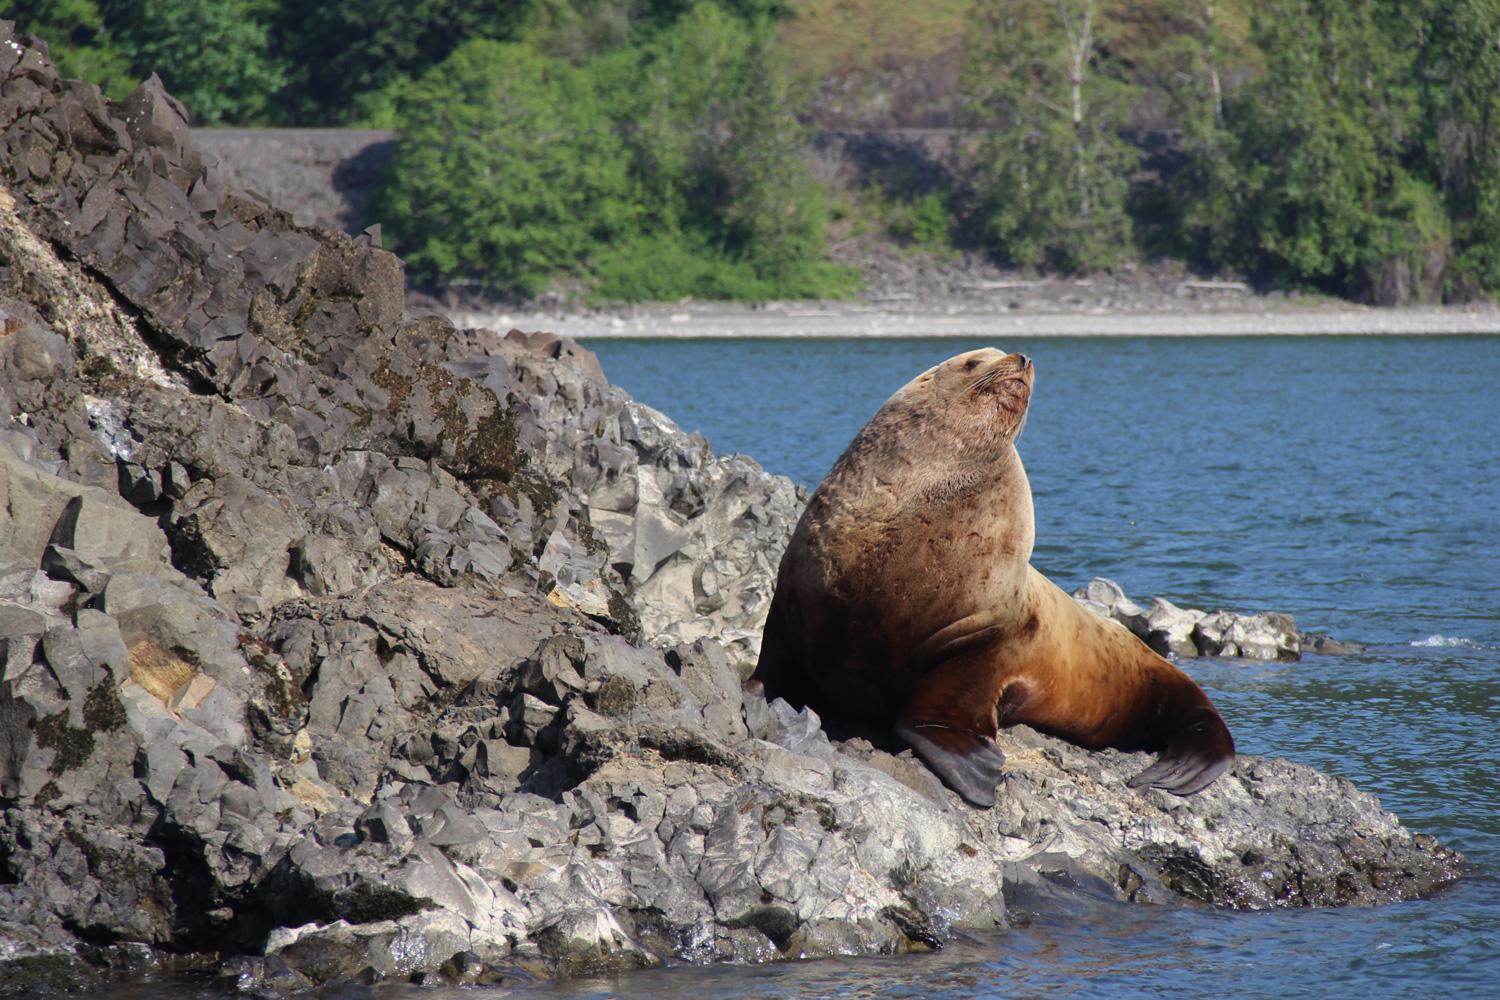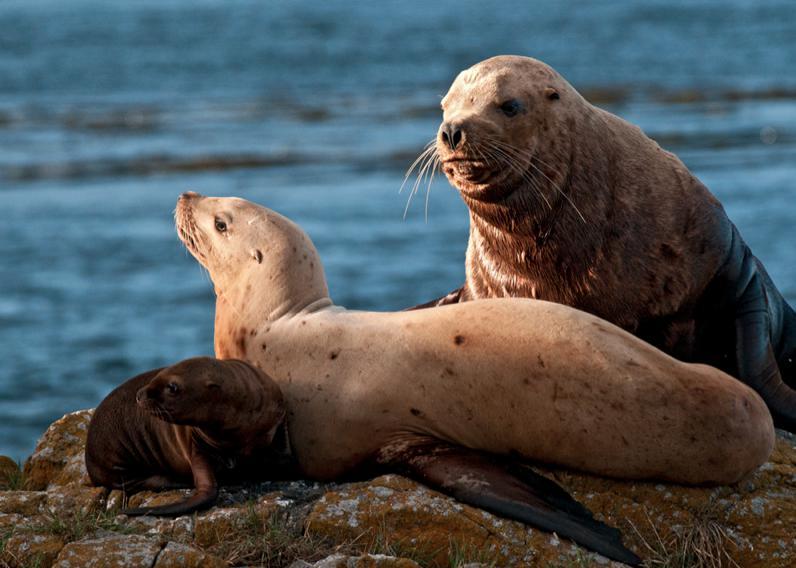The first image is the image on the left, the second image is the image on the right. Examine the images to the left and right. Is the description "In each image, a large seal has its head and shoulders upright, and the upright seals in the left and right images face the same direction." accurate? Answer yes or no. No. The first image is the image on the left, the second image is the image on the right. Evaluate the accuracy of this statement regarding the images: "The left image contains exactly one sea lion.". Is it true? Answer yes or no. Yes. 